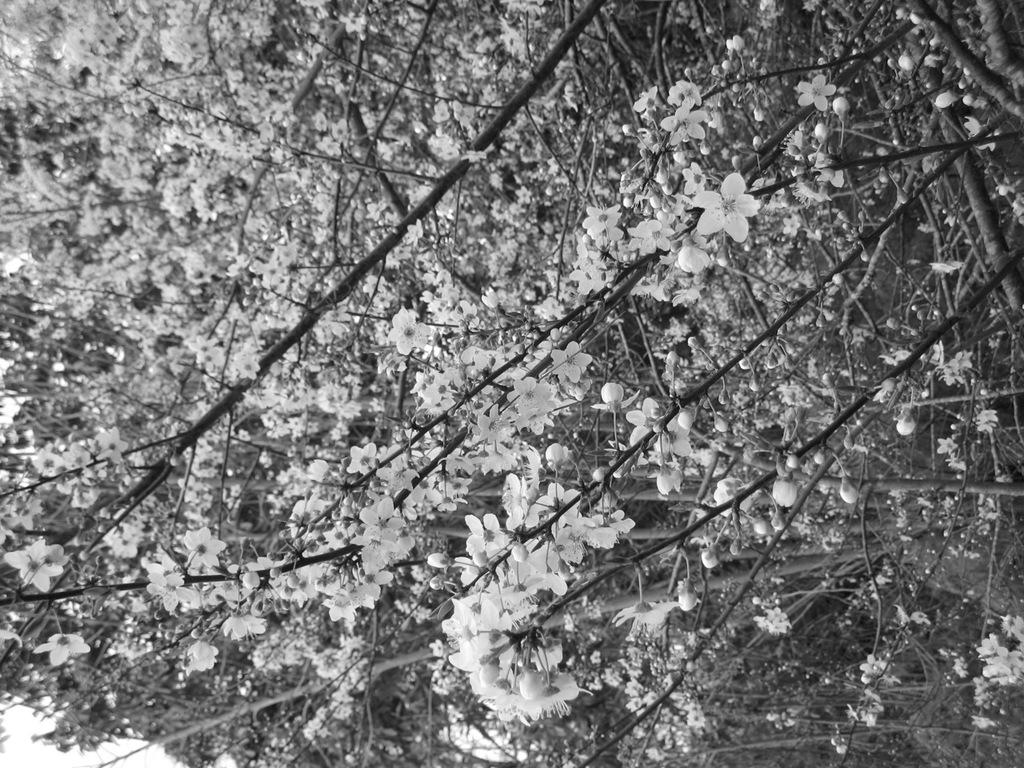What type of plants can be seen in the image? There are flowers and trees in the image. Can you describe the natural environment depicted in the image? The image features flowers and trees, which suggests a natural setting. What type of sponge can be seen in the image? There is no sponge present in the image. What type of paper is visible in the image? There is no paper visible in the image. 